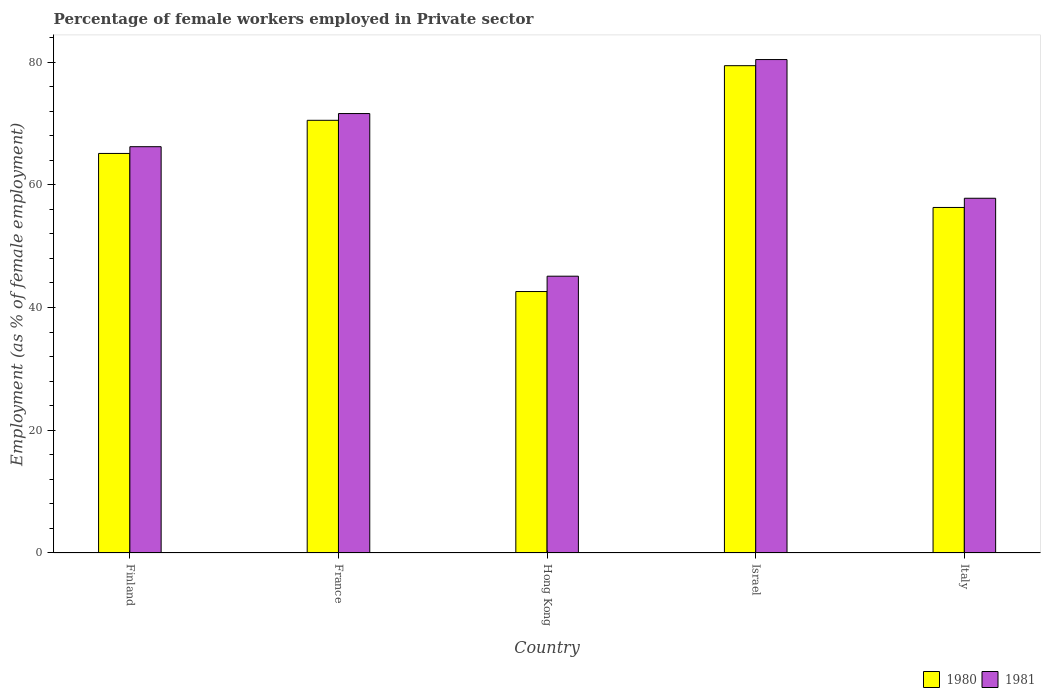How many different coloured bars are there?
Make the answer very short. 2. How many bars are there on the 1st tick from the left?
Ensure brevity in your answer.  2. How many bars are there on the 2nd tick from the right?
Your response must be concise. 2. What is the label of the 3rd group of bars from the left?
Offer a very short reply. Hong Kong. In how many cases, is the number of bars for a given country not equal to the number of legend labels?
Give a very brief answer. 0. What is the percentage of females employed in Private sector in 1981 in Italy?
Provide a succinct answer. 57.8. Across all countries, what is the maximum percentage of females employed in Private sector in 1980?
Offer a terse response. 79.4. Across all countries, what is the minimum percentage of females employed in Private sector in 1980?
Keep it short and to the point. 42.6. In which country was the percentage of females employed in Private sector in 1980 minimum?
Your response must be concise. Hong Kong. What is the total percentage of females employed in Private sector in 1981 in the graph?
Provide a short and direct response. 321.1. What is the difference between the percentage of females employed in Private sector in 1980 in Finland and that in Israel?
Provide a short and direct response. -14.3. What is the difference between the percentage of females employed in Private sector in 1981 in France and the percentage of females employed in Private sector in 1980 in Finland?
Offer a very short reply. 6.5. What is the average percentage of females employed in Private sector in 1980 per country?
Make the answer very short. 62.78. What is the difference between the percentage of females employed in Private sector of/in 1980 and percentage of females employed in Private sector of/in 1981 in Italy?
Provide a succinct answer. -1.5. In how many countries, is the percentage of females employed in Private sector in 1980 greater than 12 %?
Keep it short and to the point. 5. What is the ratio of the percentage of females employed in Private sector in 1981 in France to that in Hong Kong?
Offer a very short reply. 1.59. What is the difference between the highest and the second highest percentage of females employed in Private sector in 1981?
Your answer should be very brief. 14.2. What is the difference between the highest and the lowest percentage of females employed in Private sector in 1981?
Offer a terse response. 35.3. In how many countries, is the percentage of females employed in Private sector in 1980 greater than the average percentage of females employed in Private sector in 1980 taken over all countries?
Provide a succinct answer. 3. What does the 2nd bar from the right in Hong Kong represents?
Your response must be concise. 1980. How many countries are there in the graph?
Your response must be concise. 5. Does the graph contain any zero values?
Provide a short and direct response. No. How many legend labels are there?
Ensure brevity in your answer.  2. How are the legend labels stacked?
Your answer should be compact. Horizontal. What is the title of the graph?
Ensure brevity in your answer.  Percentage of female workers employed in Private sector. Does "1962" appear as one of the legend labels in the graph?
Keep it short and to the point. No. What is the label or title of the Y-axis?
Your answer should be very brief. Employment (as % of female employment). What is the Employment (as % of female employment) in 1980 in Finland?
Offer a very short reply. 65.1. What is the Employment (as % of female employment) of 1981 in Finland?
Provide a short and direct response. 66.2. What is the Employment (as % of female employment) in 1980 in France?
Make the answer very short. 70.5. What is the Employment (as % of female employment) of 1981 in France?
Give a very brief answer. 71.6. What is the Employment (as % of female employment) in 1980 in Hong Kong?
Your answer should be compact. 42.6. What is the Employment (as % of female employment) in 1981 in Hong Kong?
Your answer should be very brief. 45.1. What is the Employment (as % of female employment) of 1980 in Israel?
Offer a terse response. 79.4. What is the Employment (as % of female employment) of 1981 in Israel?
Ensure brevity in your answer.  80.4. What is the Employment (as % of female employment) in 1980 in Italy?
Give a very brief answer. 56.3. What is the Employment (as % of female employment) of 1981 in Italy?
Your answer should be very brief. 57.8. Across all countries, what is the maximum Employment (as % of female employment) in 1980?
Offer a very short reply. 79.4. Across all countries, what is the maximum Employment (as % of female employment) in 1981?
Your response must be concise. 80.4. Across all countries, what is the minimum Employment (as % of female employment) of 1980?
Make the answer very short. 42.6. Across all countries, what is the minimum Employment (as % of female employment) in 1981?
Provide a succinct answer. 45.1. What is the total Employment (as % of female employment) in 1980 in the graph?
Your answer should be compact. 313.9. What is the total Employment (as % of female employment) of 1981 in the graph?
Your answer should be very brief. 321.1. What is the difference between the Employment (as % of female employment) of 1980 in Finland and that in Hong Kong?
Offer a terse response. 22.5. What is the difference between the Employment (as % of female employment) in 1981 in Finland and that in Hong Kong?
Ensure brevity in your answer.  21.1. What is the difference between the Employment (as % of female employment) in 1980 in Finland and that in Israel?
Ensure brevity in your answer.  -14.3. What is the difference between the Employment (as % of female employment) in 1981 in Finland and that in Israel?
Keep it short and to the point. -14.2. What is the difference between the Employment (as % of female employment) in 1980 in France and that in Hong Kong?
Your answer should be very brief. 27.9. What is the difference between the Employment (as % of female employment) in 1980 in France and that in Israel?
Give a very brief answer. -8.9. What is the difference between the Employment (as % of female employment) of 1980 in France and that in Italy?
Your answer should be very brief. 14.2. What is the difference between the Employment (as % of female employment) of 1981 in France and that in Italy?
Provide a succinct answer. 13.8. What is the difference between the Employment (as % of female employment) of 1980 in Hong Kong and that in Israel?
Your answer should be very brief. -36.8. What is the difference between the Employment (as % of female employment) of 1981 in Hong Kong and that in Israel?
Keep it short and to the point. -35.3. What is the difference between the Employment (as % of female employment) of 1980 in Hong Kong and that in Italy?
Keep it short and to the point. -13.7. What is the difference between the Employment (as % of female employment) of 1981 in Hong Kong and that in Italy?
Your response must be concise. -12.7. What is the difference between the Employment (as % of female employment) in 1980 in Israel and that in Italy?
Make the answer very short. 23.1. What is the difference between the Employment (as % of female employment) in 1981 in Israel and that in Italy?
Keep it short and to the point. 22.6. What is the difference between the Employment (as % of female employment) of 1980 in Finland and the Employment (as % of female employment) of 1981 in Israel?
Give a very brief answer. -15.3. What is the difference between the Employment (as % of female employment) of 1980 in France and the Employment (as % of female employment) of 1981 in Hong Kong?
Give a very brief answer. 25.4. What is the difference between the Employment (as % of female employment) of 1980 in Hong Kong and the Employment (as % of female employment) of 1981 in Israel?
Your response must be concise. -37.8. What is the difference between the Employment (as % of female employment) in 1980 in Hong Kong and the Employment (as % of female employment) in 1981 in Italy?
Ensure brevity in your answer.  -15.2. What is the difference between the Employment (as % of female employment) of 1980 in Israel and the Employment (as % of female employment) of 1981 in Italy?
Give a very brief answer. 21.6. What is the average Employment (as % of female employment) in 1980 per country?
Provide a succinct answer. 62.78. What is the average Employment (as % of female employment) of 1981 per country?
Provide a short and direct response. 64.22. What is the difference between the Employment (as % of female employment) in 1980 and Employment (as % of female employment) in 1981 in Finland?
Give a very brief answer. -1.1. What is the difference between the Employment (as % of female employment) of 1980 and Employment (as % of female employment) of 1981 in Israel?
Provide a short and direct response. -1. What is the difference between the Employment (as % of female employment) in 1980 and Employment (as % of female employment) in 1981 in Italy?
Your answer should be very brief. -1.5. What is the ratio of the Employment (as % of female employment) in 1980 in Finland to that in France?
Ensure brevity in your answer.  0.92. What is the ratio of the Employment (as % of female employment) in 1981 in Finland to that in France?
Keep it short and to the point. 0.92. What is the ratio of the Employment (as % of female employment) of 1980 in Finland to that in Hong Kong?
Provide a short and direct response. 1.53. What is the ratio of the Employment (as % of female employment) in 1981 in Finland to that in Hong Kong?
Offer a terse response. 1.47. What is the ratio of the Employment (as % of female employment) of 1980 in Finland to that in Israel?
Keep it short and to the point. 0.82. What is the ratio of the Employment (as % of female employment) of 1981 in Finland to that in Israel?
Offer a terse response. 0.82. What is the ratio of the Employment (as % of female employment) in 1980 in Finland to that in Italy?
Your response must be concise. 1.16. What is the ratio of the Employment (as % of female employment) in 1981 in Finland to that in Italy?
Your answer should be compact. 1.15. What is the ratio of the Employment (as % of female employment) in 1980 in France to that in Hong Kong?
Provide a succinct answer. 1.65. What is the ratio of the Employment (as % of female employment) of 1981 in France to that in Hong Kong?
Give a very brief answer. 1.59. What is the ratio of the Employment (as % of female employment) of 1980 in France to that in Israel?
Keep it short and to the point. 0.89. What is the ratio of the Employment (as % of female employment) of 1981 in France to that in Israel?
Make the answer very short. 0.89. What is the ratio of the Employment (as % of female employment) of 1980 in France to that in Italy?
Your response must be concise. 1.25. What is the ratio of the Employment (as % of female employment) in 1981 in France to that in Italy?
Keep it short and to the point. 1.24. What is the ratio of the Employment (as % of female employment) of 1980 in Hong Kong to that in Israel?
Provide a short and direct response. 0.54. What is the ratio of the Employment (as % of female employment) of 1981 in Hong Kong to that in Israel?
Provide a succinct answer. 0.56. What is the ratio of the Employment (as % of female employment) in 1980 in Hong Kong to that in Italy?
Offer a very short reply. 0.76. What is the ratio of the Employment (as % of female employment) in 1981 in Hong Kong to that in Italy?
Make the answer very short. 0.78. What is the ratio of the Employment (as % of female employment) of 1980 in Israel to that in Italy?
Make the answer very short. 1.41. What is the ratio of the Employment (as % of female employment) of 1981 in Israel to that in Italy?
Make the answer very short. 1.39. What is the difference between the highest and the second highest Employment (as % of female employment) in 1980?
Offer a terse response. 8.9. What is the difference between the highest and the lowest Employment (as % of female employment) in 1980?
Provide a short and direct response. 36.8. What is the difference between the highest and the lowest Employment (as % of female employment) in 1981?
Ensure brevity in your answer.  35.3. 